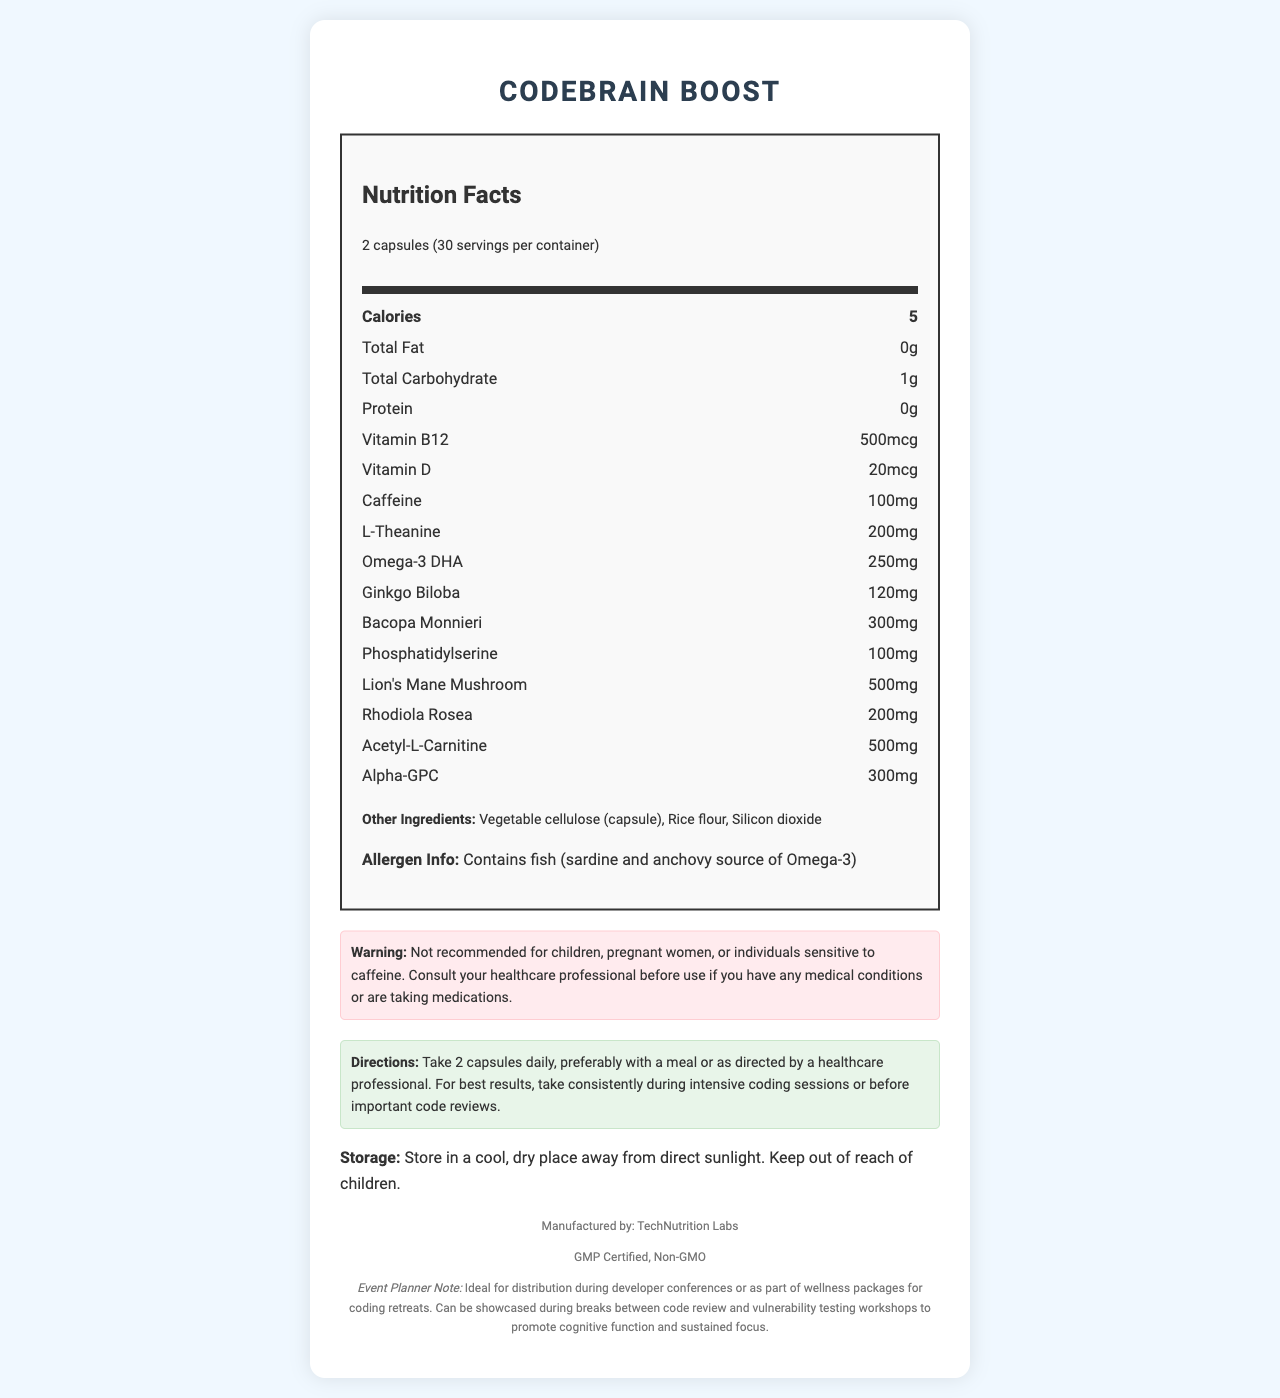what is the serving size? The document specifies "2 capsules" as the serving size in the "serving info" section.
Answer: 2 capsules how many calories are in one serving? The document states that each serving contains 5 calories in the "Calories" section of the nutrition label.
Answer: 5 which ingredient provides omega-3 DHA? The document lists "Contains fish (sardine and anchovy source of Omega-3)" in the Allergen Info section.
Answer: Fish (sardine and anchovy) how much caffeine is in one serving? The nutrition label shows that each serving contains 100mg of caffeine.
Answer: 100mg what warning is given for children? The Warning section explicitly states "Not recommended for children."
Answer: Not recommended for children how much alpha-GPC is present in one serving? The nutrition label indicates that one serving contains 300mg of alpha-GPC.
Answer: 300mg what is the recommended usage for best results? The Directions section advises to "Take consistently during intensive coding sessions or before important code reviews."
Answer: Take consistently during intensive coding sessions or before important code reviews which of the following is a potential allergen mentioned in the document? A. Gluten B. Fish C. Milk D. Soy The document mentions "Contains fish (sardine and anchovy source of Omega-3)" under the Allergen Info section.
Answer: B. Fish how many servings are in the container? A. 20 B. 30 C. 40 D. 50 The "servings per container" information states there are 30 servings per container.
Answer: B. 30 is it safe for pregnant women to take this supplement? The Warning section states "Not recommended for children, pregnant women, or individuals sensitive to caffeine."
Answer: No where should this product be stored? The Storage section advises to "Store in a cool, dry place away from direct sunlight."
Answer: In a cool, dry place away from direct sunlight describe the main idea of the document. The document contains comprehensive details about the "CodeBrain Boost" supplement, highlighting its nutritional components, instructions for use, storage recommendations, and target audience, which is developers engaged in rigorous mental activities.
Answer: The document provides nutritional information and usage instructions for "CodeBrain Boost," a brain-boosting supplement designed for software engineers. It includes details about serving size, ingredients, allergens, and warnings against use by children, pregnant women, and individuals sensitive to caffeine. The supplement is promoted for use during intensive coding sessions and code reviews to enhance cognitive function. what is the ingredient used for the capsule? The document lists "Vegetable cellulose (capsule)" under the Other Ingredients section.
Answer: Vegetable cellulose who manufactures this product? The document states that the product is manufactured by "TechNutrition Labs" in the footer section.
Answer: TechNutrition Labs how many grams of protein are in each serving? The Nutrition Facts label shows that each serving includes 0g of protein.
Answer: 0g is this supplement suitable for someone allergic to milk? The document mentions fish as an allergen but does not provide information about the presence or absence of milk or milk products.
Answer: Cannot be determined 